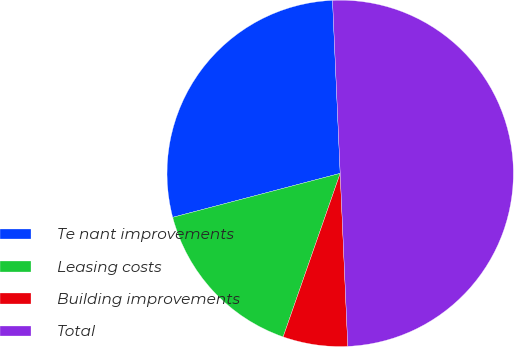Convert chart to OTSL. <chart><loc_0><loc_0><loc_500><loc_500><pie_chart><fcel>Te nant improvements<fcel>Leasing costs<fcel>Building improvements<fcel>Total<nl><fcel>28.38%<fcel>15.57%<fcel>6.04%<fcel>50.0%<nl></chart> 